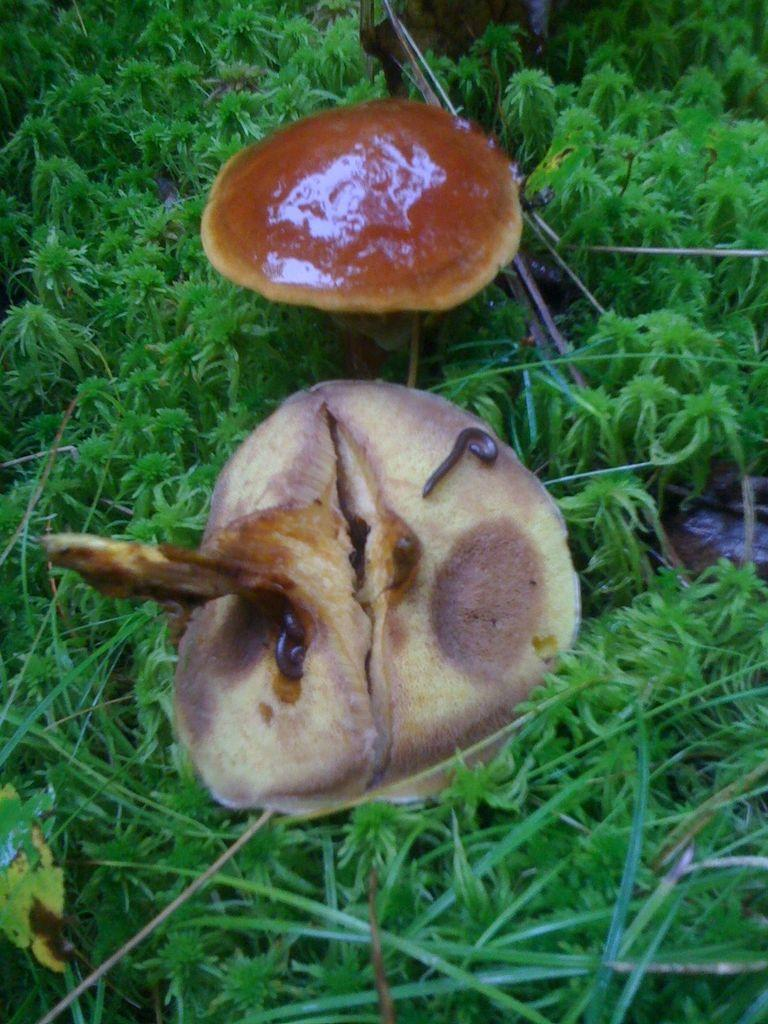How many mushrooms are present in the image? There are two mushrooms in the image. What can be seen in the background of the image? There is grass in the background of the image. What is the color of the grass? The grass is green in color. What type of plate is being used to serve the mushrooms in the image? There is no plate present in the image, as the mushrooms are not being served or prepared for consumption. 